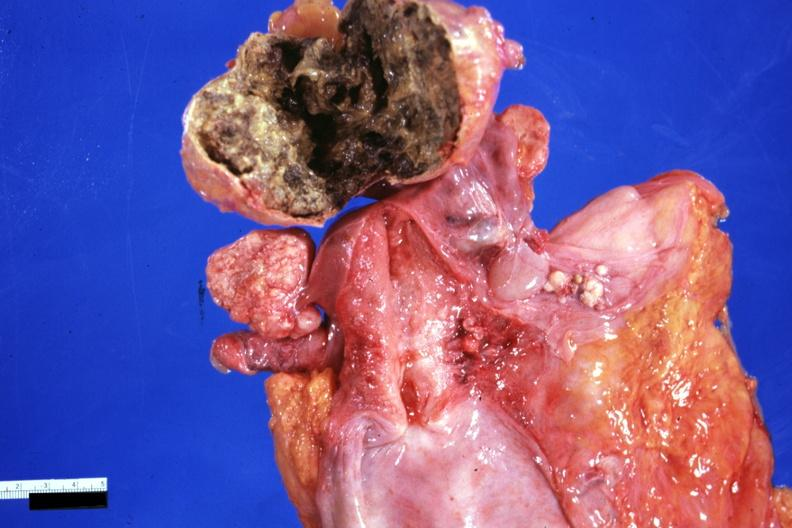what is present?
Answer the question using a single word or phrase. Female reproductive 